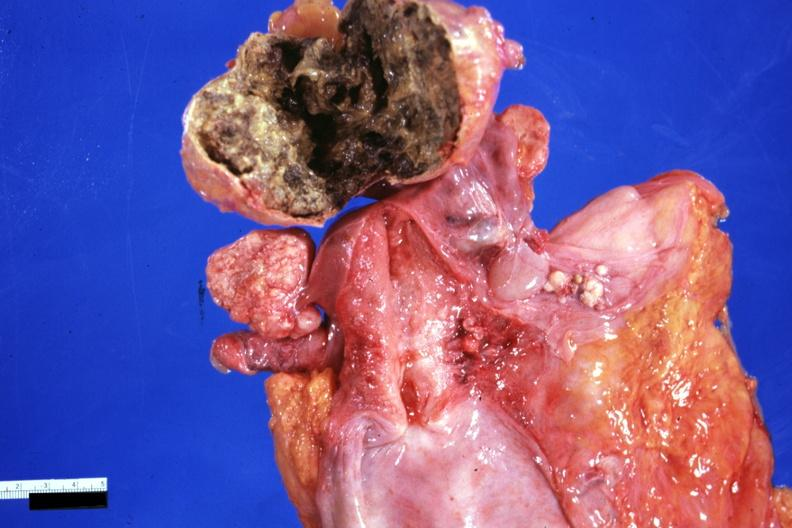what is present?
Answer the question using a single word or phrase. Female reproductive 